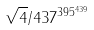<formula> <loc_0><loc_0><loc_500><loc_500>\sqrt { 4 } / 4 3 7 ^ { 3 9 5 ^ { 4 3 9 } }</formula> 